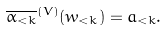<formula> <loc_0><loc_0><loc_500><loc_500>\overline { \alpha _ { < k } } ^ { ( V ) } ( w _ { < k } ) = a _ { < k } .</formula> 